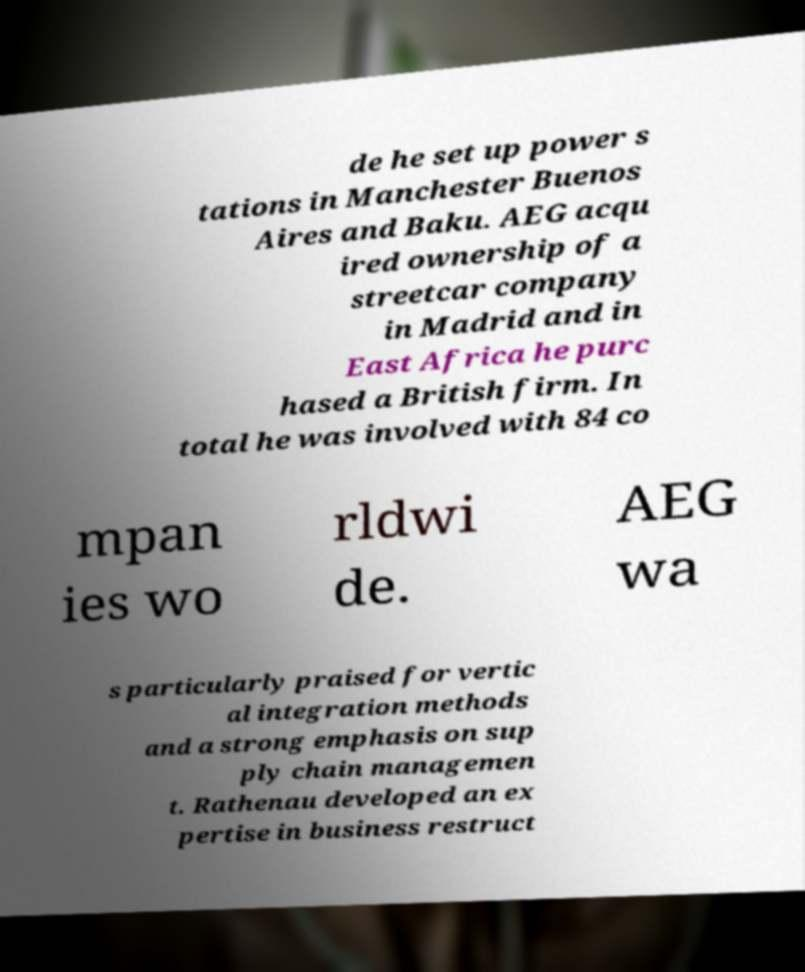There's text embedded in this image that I need extracted. Can you transcribe it verbatim? de he set up power s tations in Manchester Buenos Aires and Baku. AEG acqu ired ownership of a streetcar company in Madrid and in East Africa he purc hased a British firm. In total he was involved with 84 co mpan ies wo rldwi de. AEG wa s particularly praised for vertic al integration methods and a strong emphasis on sup ply chain managemen t. Rathenau developed an ex pertise in business restruct 